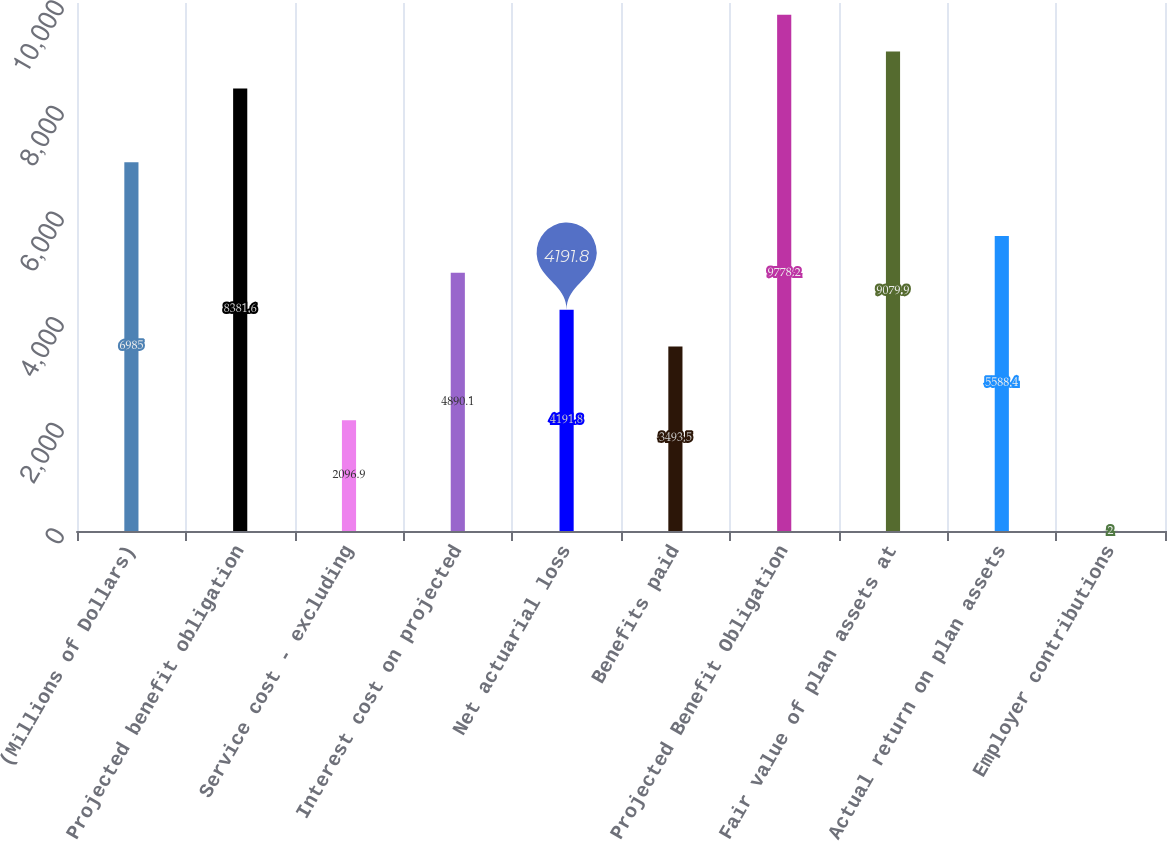Convert chart. <chart><loc_0><loc_0><loc_500><loc_500><bar_chart><fcel>(Millions of Dollars)<fcel>Projected benefit obligation<fcel>Service cost - excluding<fcel>Interest cost on projected<fcel>Net actuarial loss<fcel>Benefits paid<fcel>Projected Benefit Obligation<fcel>Fair value of plan assets at<fcel>Actual return on plan assets<fcel>Employer contributions<nl><fcel>6985<fcel>8381.6<fcel>2096.9<fcel>4890.1<fcel>4191.8<fcel>3493.5<fcel>9778.2<fcel>9079.9<fcel>5588.4<fcel>2<nl></chart> 